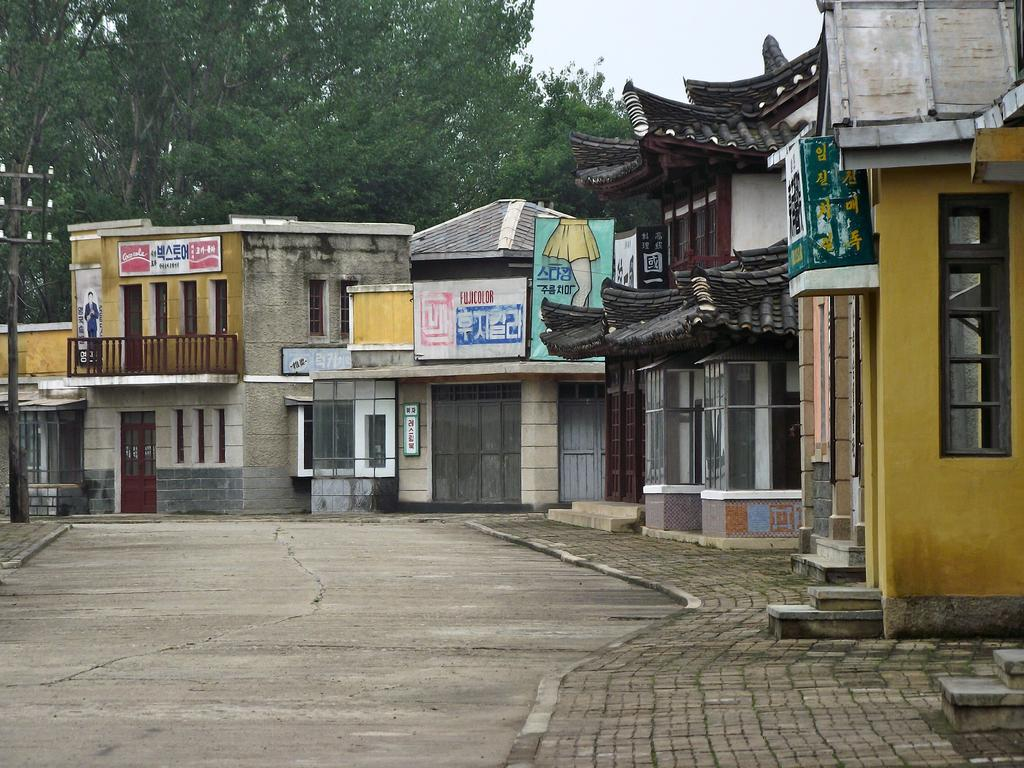What type of structures can be seen in the image? There are buildings in the image. What features are present on the buildings? There are doors and windows visible on the buildings. What signage can be seen on the walls of the buildings? There are name boards on the walls in the image. What type of vegetation is present in the image? There are trees in the image. What other objects can be seen in the image? There are poles in the image. What is visible in the sky in the image? There are clouds in the sky in the image. What is at the bottom of the image? There is a road visible at the bottom of the image. How much profit is the van making in the image? There is no van present in the image, so it is not possible to determine the profit. What type of error can be seen on the name boards in the image? There are no errors visible on the name boards in the image. 